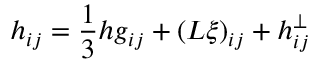Convert formula to latex. <formula><loc_0><loc_0><loc_500><loc_500>h _ { i j } = \frac { 1 } { 3 } h g _ { i j } + \left ( L \xi \right ) _ { i j } + h _ { i j } ^ { \bot }</formula> 